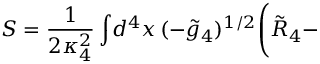Convert formula to latex. <formula><loc_0><loc_0><loc_500><loc_500>S = \frac { 1 } { 2 \kappa _ { 4 } ^ { 2 } } \int \, d ^ { 4 } x \, ( - \tilde { g } _ { 4 } ) ^ { 1 / 2 } \Big ( \tilde { R } _ { 4 } -</formula> 